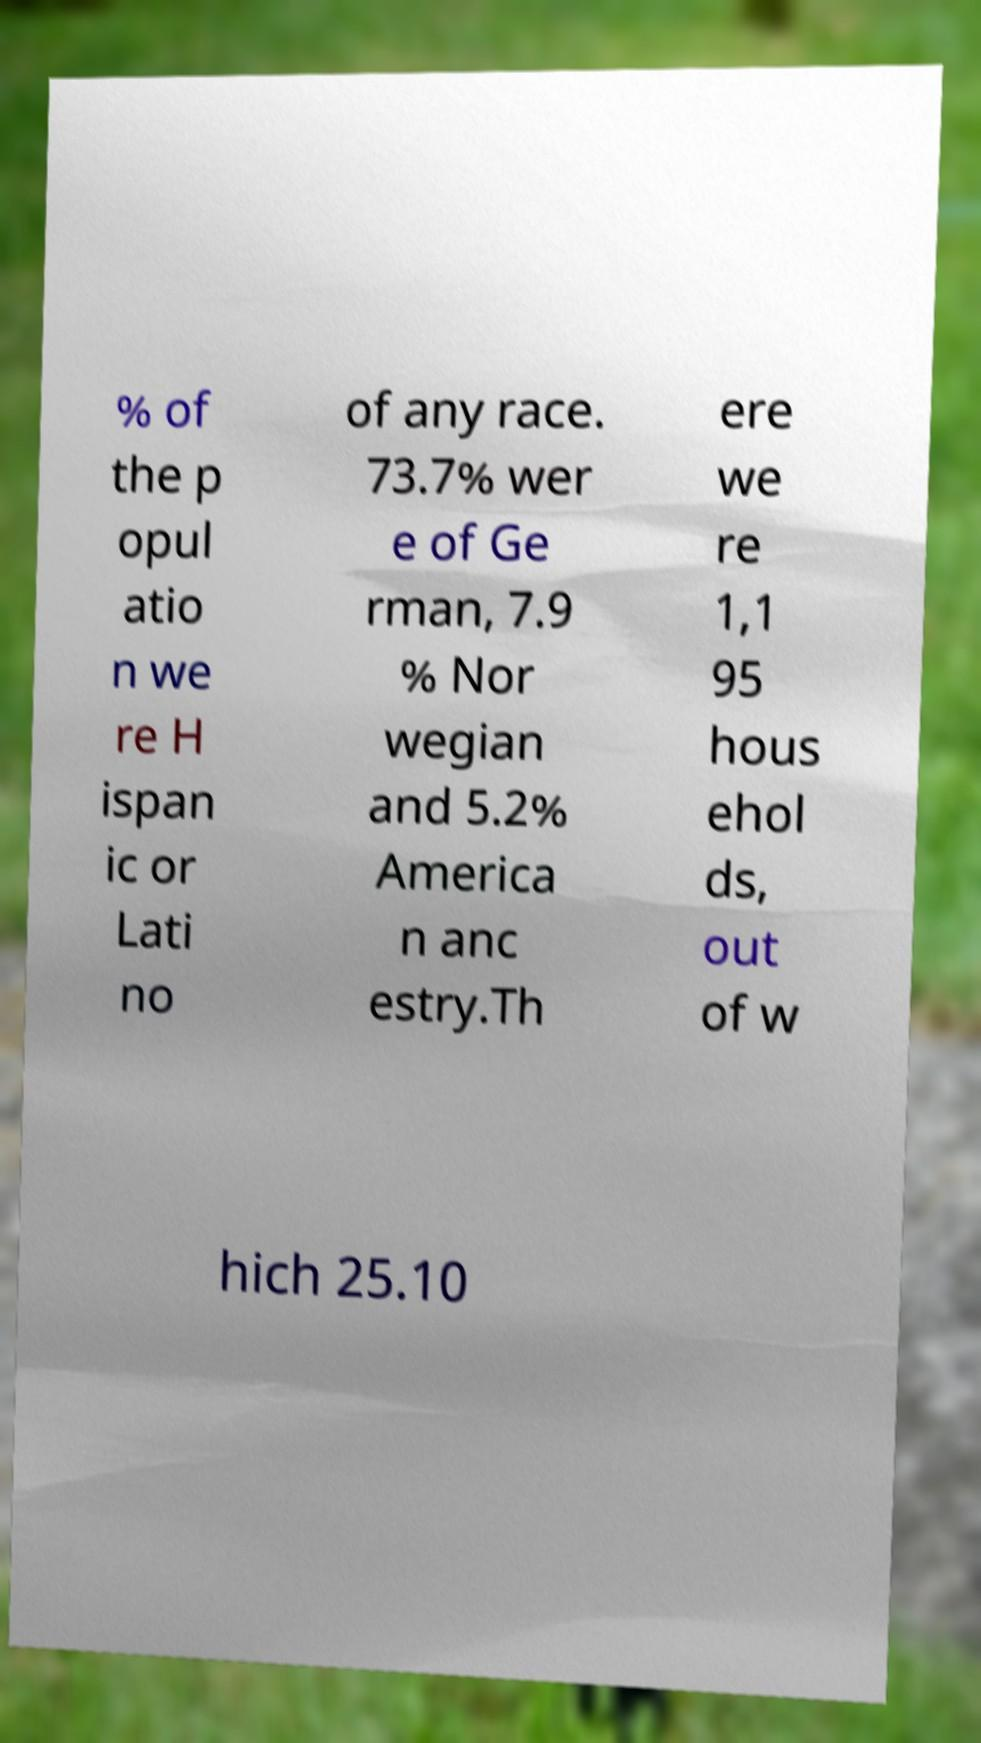Please read and relay the text visible in this image. What does it say? % of the p opul atio n we re H ispan ic or Lati no of any race. 73.7% wer e of Ge rman, 7.9 % Nor wegian and 5.2% America n anc estry.Th ere we re 1,1 95 hous ehol ds, out of w hich 25.10 